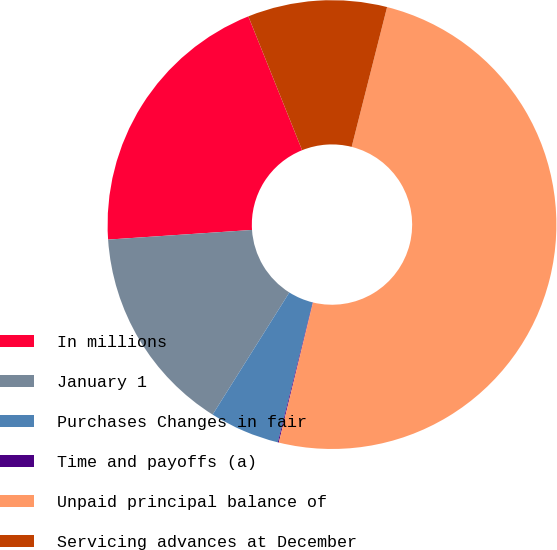<chart> <loc_0><loc_0><loc_500><loc_500><pie_chart><fcel>In millions<fcel>January 1<fcel>Purchases Changes in fair<fcel>Time and payoffs (a)<fcel>Unpaid principal balance of<fcel>Servicing advances at December<nl><fcel>19.99%<fcel>15.01%<fcel>5.05%<fcel>0.07%<fcel>49.87%<fcel>10.03%<nl></chart> 